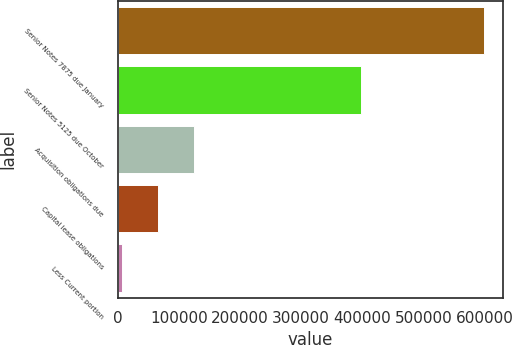Convert chart to OTSL. <chart><loc_0><loc_0><loc_500><loc_500><bar_chart><fcel>Senior Notes 7875 due January<fcel>Senior Notes 5125 due October<fcel>Acquisition obligations due<fcel>Capital lease obligations<fcel>Less Current portion<nl><fcel>599414<fcel>398471<fcel>125712<fcel>66498.8<fcel>7286<nl></chart> 